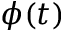<formula> <loc_0><loc_0><loc_500><loc_500>\phi ( t )</formula> 